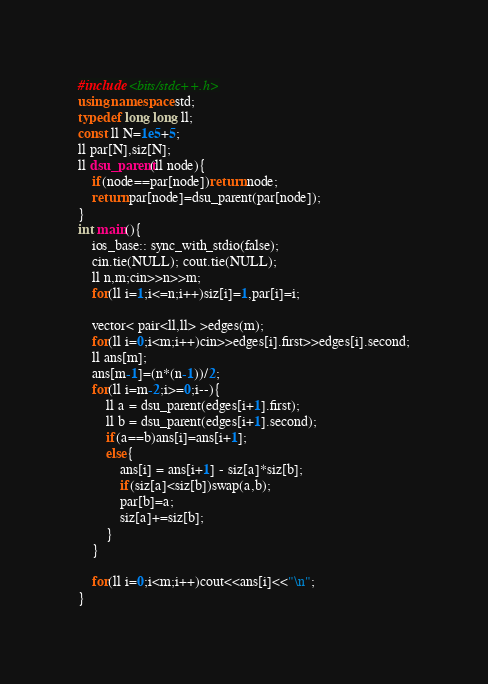<code> <loc_0><loc_0><loc_500><loc_500><_C++_>#include <bits/stdc++.h>
using namespace std;
typedef long long ll;
const ll N=1e5+5;
ll par[N],siz[N];
ll dsu_parent(ll node){
    if(node==par[node])return node;
    return par[node]=dsu_parent(par[node]);
}
int main(){
    ios_base:: sync_with_stdio(false);
    cin.tie(NULL); cout.tie(NULL);
    ll n,m;cin>>n>>m;
    for(ll i=1;i<=n;i++)siz[i]=1,par[i]=i;

    vector< pair<ll,ll> >edges(m);
    for(ll i=0;i<m;i++)cin>>edges[i].first>>edges[i].second;
    ll ans[m];
    ans[m-1]=(n*(n-1))/2;
    for(ll i=m-2;i>=0;i--){
        ll a = dsu_parent(edges[i+1].first);
        ll b = dsu_parent(edges[i+1].second);
        if(a==b)ans[i]=ans[i+1];
        else{
            ans[i] = ans[i+1] - siz[a]*siz[b];
            if(siz[a]<siz[b])swap(a,b);
            par[b]=a;
            siz[a]+=siz[b];
        }
    }

    for(ll i=0;i<m;i++)cout<<ans[i]<<"\n";
}


</code> 